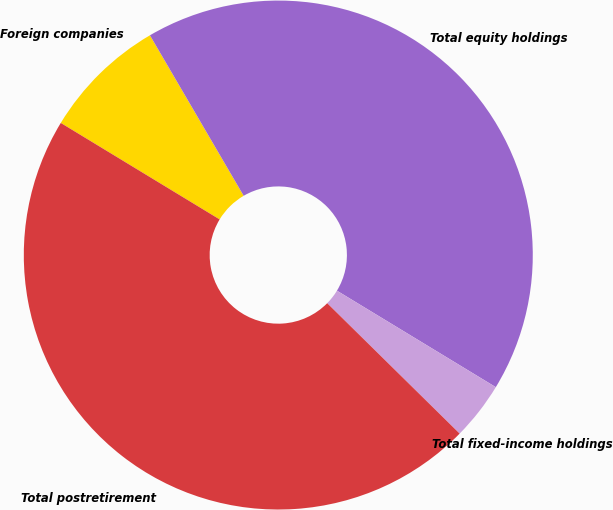Convert chart. <chart><loc_0><loc_0><loc_500><loc_500><pie_chart><fcel>Foreign companies<fcel>Total equity holdings<fcel>Total fixed-income holdings<fcel>Total postretirement<nl><fcel>7.9%<fcel>42.1%<fcel>3.69%<fcel>46.31%<nl></chart> 